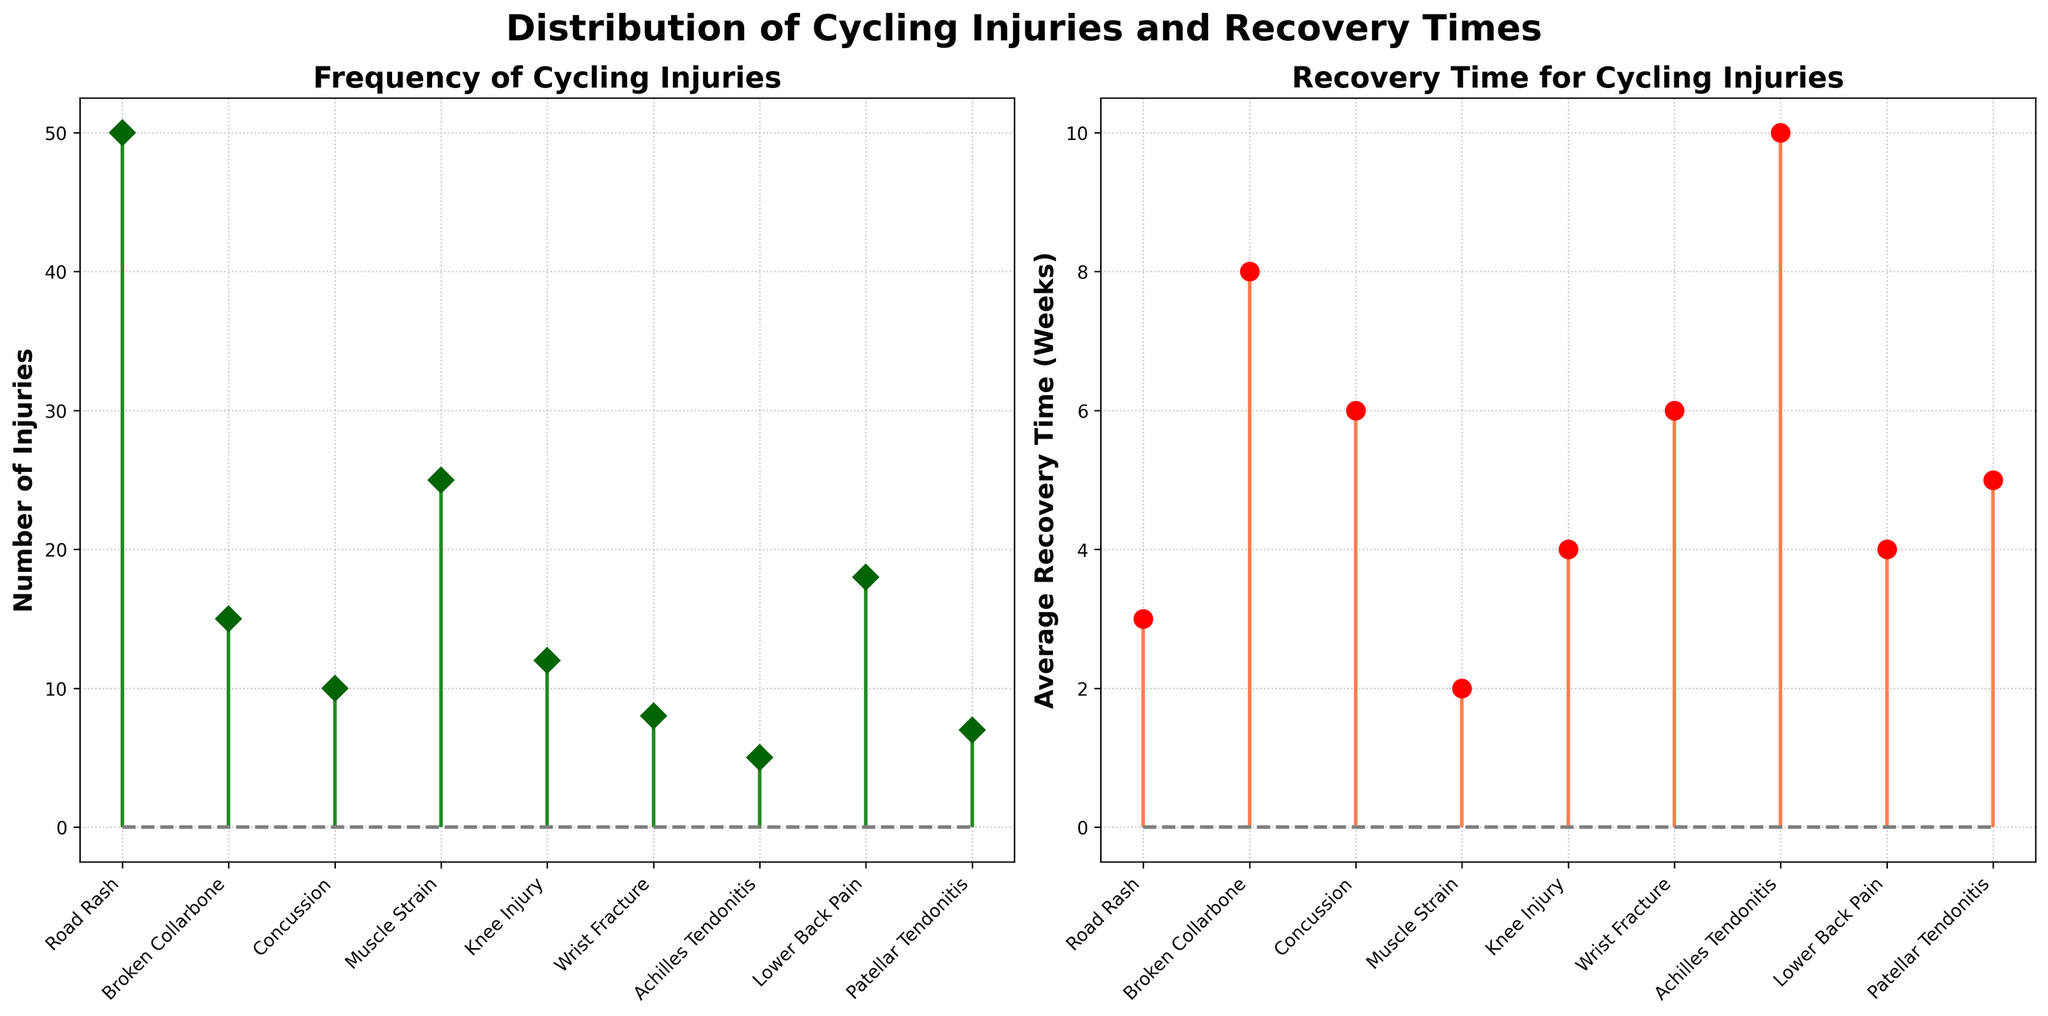Which injury type has the highest number of injuries? The first subplot shows the number of injuries for each type of injury. "Road Rash" has the highest marker on the y-axis, indicating the highest number of injuries.
Answer: Road Rash What's the average recovery time for Achilles Tendonitis? The second subplot shows the average recovery time for each injury type. "Achilles Tendonitis" has a marker corresponding to a recovery time of 10 weeks.
Answer: 10 weeks How many injury types have a recovery time of 6 weeks? By counting the markers at 6 weeks in the second subplot, we can see that they correspond to "Concussion" and "Wrist Fracture."
Answer: 2 injury types Which injury type has the shortest average recovery time? From the second subplot, the marker with the lowest y-value indicates the shortest average recovery time. "Muscle Strain" has the lowest marker.
Answer: Muscle Strain How many total injuries are represented in the first subplot? Summing all the values for the number of injuries from the first subplot yields the total number of injuries: 50 + 15 + 10 + 25 + 12 + 8 + 5 + 18 + 7. This equals 150.
Answer: 150 Which injury type has an average recovery time equal to that of a concussion? By looking at the markers in the second subplot, we see that "Concussion" and "Wrist Fracture" both have the same recovery time of 6 weeks.
Answer: Wrist Fracture Is the average recovery time for a knee injury longer or shorter than that of lower back pain? The second subplot shows "Knee Injury" and "Lower Back Pain." Comparing their markers, Lower Back Pain has a lower recovery time (4 weeks) compared to the Knee Injury (4 weeks). Thus, they are equal.
Answer: Equal Which injury type has fewer than 10 injuries but an average recovery time over 5 weeks? From both subplots, Achilles Tendonitis has 5 injuries and a recovery time of 10 weeks.
Answer: Achilles Tendonitis How does the number of injuries for a broken collarbone compare to that of a knee injury? The first subplot indicates that "Broken Collarbone" has a marker at 15 injuries, while "Knee Injury" has a marker at 12 injuries. Hence, "Broken Collarbone" has more injuries.
Answer: Broken Collarbone has more What is the sum of the average recovery times for Road Rash and Patellar Tendonitis? The second subplot shows that the recovery times for Road Rash and Patellar Tendonitis are 3 weeks and 5 weeks, respectively. Adding these gives 3 + 5 = 8 weeks.
Answer: 8 weeks 